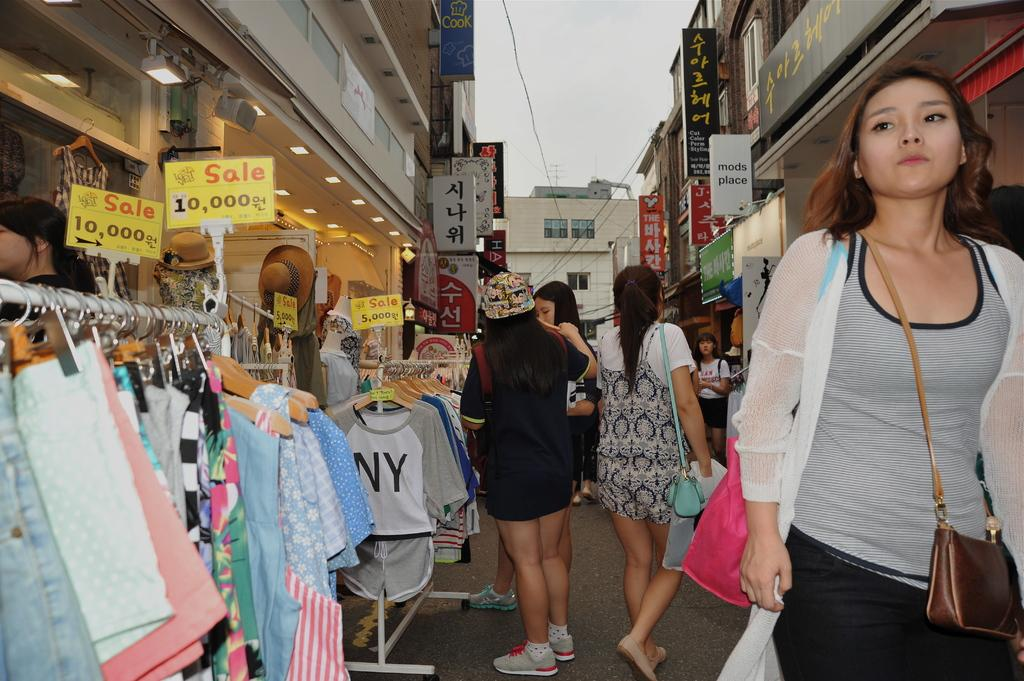How many people are present in the image? There are four ladies standing in the image. What can be seen hanging beside the ladies? Clothes are hanged on a rod beside the ladies. What is visible in the background of the image? There are buildings on either side of the ladies. What type of alarm is ringing in the image? There is no alarm present in the image. Are the ladies wearing mittens in the image? There is no mention of mittens in the image, and none are visible on the ladies. 